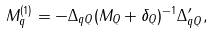Convert formula to latex. <formula><loc_0><loc_0><loc_500><loc_500>M _ { q } ^ { ( 1 ) } = - \Delta _ { q Q } ( M _ { Q } + \delta _ { Q } ) ^ { - 1 } \Delta _ { q Q } ^ { \prime } ,</formula> 